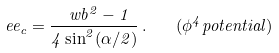Convert formula to latex. <formula><loc_0><loc_0><loc_500><loc_500>\ e e _ { c } = \frac { \ w b ^ { 2 } - 1 } { 4 \sin ^ { 2 } ( \alpha / 2 ) } \, . \quad ( \phi ^ { 4 } p o t e n t i a l )</formula> 